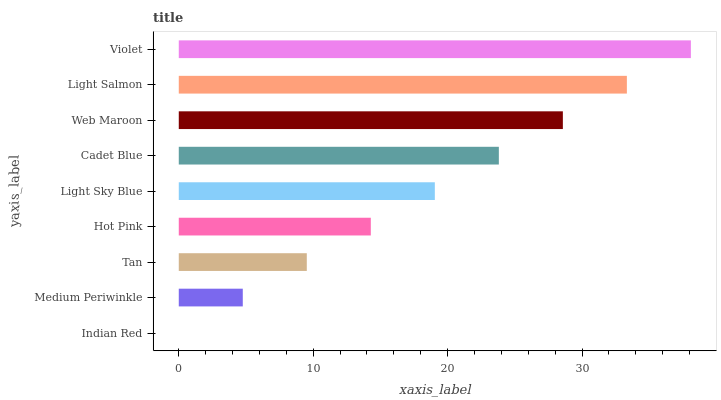Is Indian Red the minimum?
Answer yes or no. Yes. Is Violet the maximum?
Answer yes or no. Yes. Is Medium Periwinkle the minimum?
Answer yes or no. No. Is Medium Periwinkle the maximum?
Answer yes or no. No. Is Medium Periwinkle greater than Indian Red?
Answer yes or no. Yes. Is Indian Red less than Medium Periwinkle?
Answer yes or no. Yes. Is Indian Red greater than Medium Periwinkle?
Answer yes or no. No. Is Medium Periwinkle less than Indian Red?
Answer yes or no. No. Is Light Sky Blue the high median?
Answer yes or no. Yes. Is Light Sky Blue the low median?
Answer yes or no. Yes. Is Web Maroon the high median?
Answer yes or no. No. Is Cadet Blue the low median?
Answer yes or no. No. 